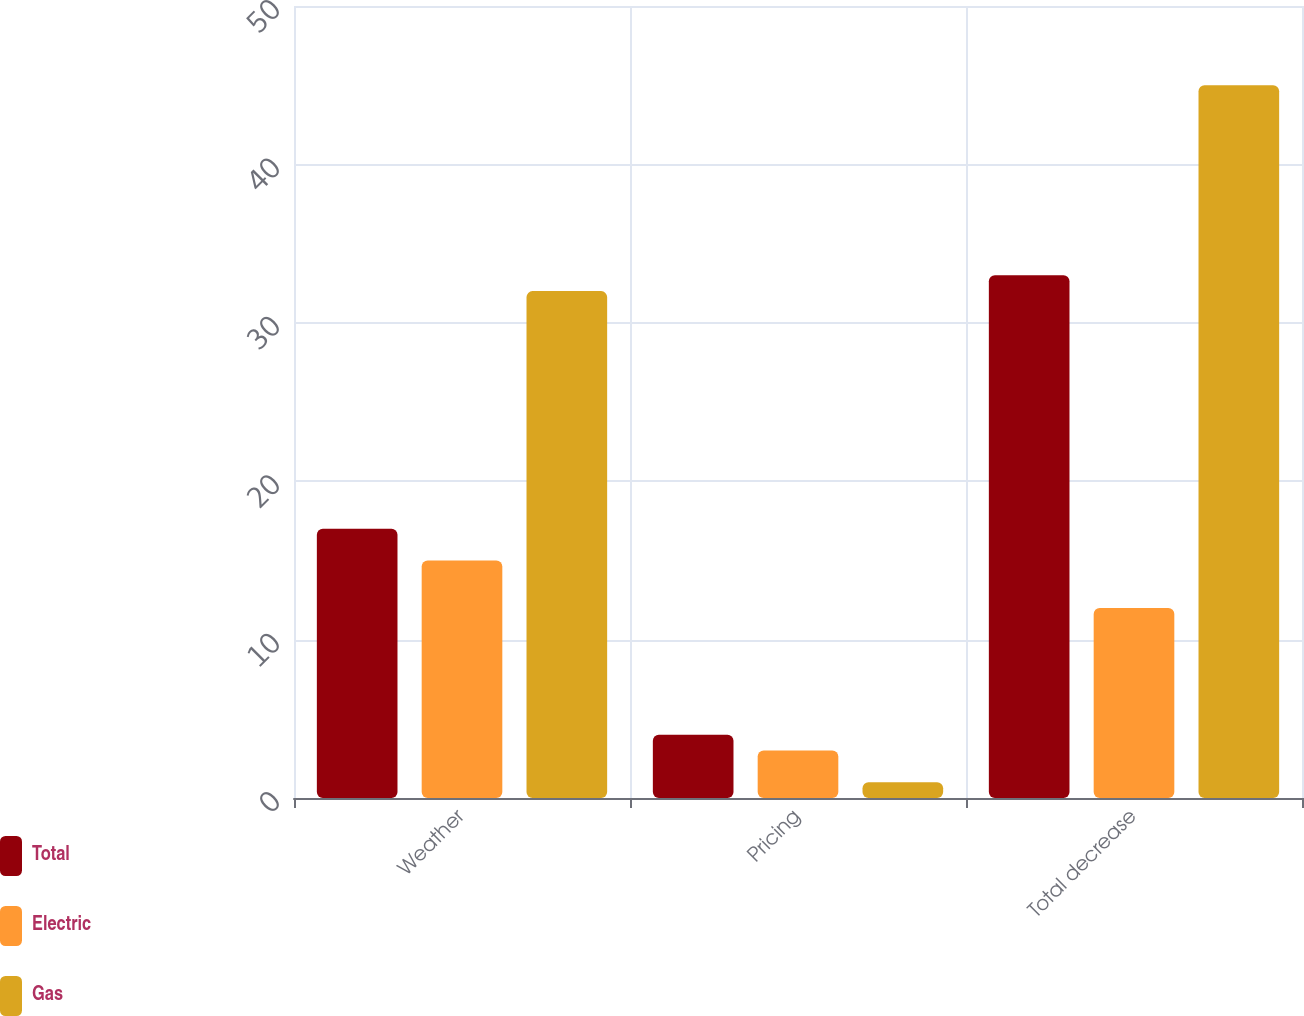<chart> <loc_0><loc_0><loc_500><loc_500><stacked_bar_chart><ecel><fcel>Weather<fcel>Pricing<fcel>Total decrease<nl><fcel>Total<fcel>17<fcel>4<fcel>33<nl><fcel>Electric<fcel>15<fcel>3<fcel>12<nl><fcel>Gas<fcel>32<fcel>1<fcel>45<nl></chart> 